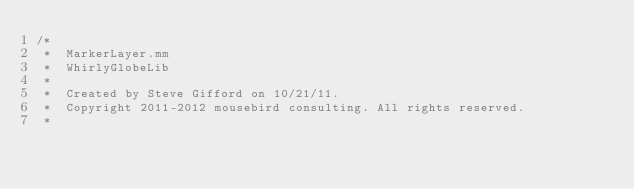<code> <loc_0><loc_0><loc_500><loc_500><_ObjectiveC_>/*
 *  MarkerLayer.mm
 *  WhirlyGlobeLib
 *
 *  Created by Steve Gifford on 10/21/11.
 *  Copyright 2011-2012 mousebird consulting. All rights reserved.
 *</code> 